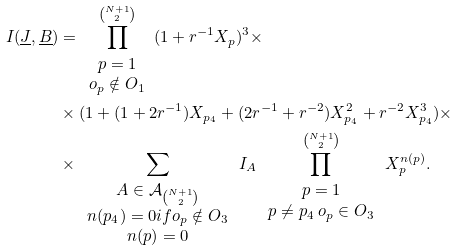Convert formula to latex. <formula><loc_0><loc_0><loc_500><loc_500>I ( \underline { J } , \underline { B } ) & = \prod _ { \begin{array} { c } p = 1 \\ o _ { p } \notin O _ { 1 } \end{array} } ^ { \binom { N + 1 } { 2 } } ( 1 + r ^ { - 1 } X _ { p } ) ^ { 3 } \times \\ & \times ( 1 + ( 1 + 2 r ^ { - 1 } ) X _ { p _ { 4 } } + ( 2 r ^ { - 1 } + r ^ { - 2 } ) X _ { p _ { 4 } } ^ { 2 } + r ^ { - 2 } X _ { p _ { 4 } } ^ { 3 } ) \times \\ & \times \sum _ { \begin{array} { c } A \in \mathcal { A } _ { \binom { N + 1 } { 2 } } \\ n ( p _ { 4 } ) = 0 i f o _ { p } \notin O _ { 3 } \\ n ( p ) = 0 \end{array} } I _ { A } \prod _ { \begin{array} { c } p = 1 \\ p \neq p _ { 4 } \, o _ { p } \in O _ { 3 } \end{array} } ^ { \binom { N + 1 } { 2 } } X _ { p } ^ { n ( p ) } .</formula> 